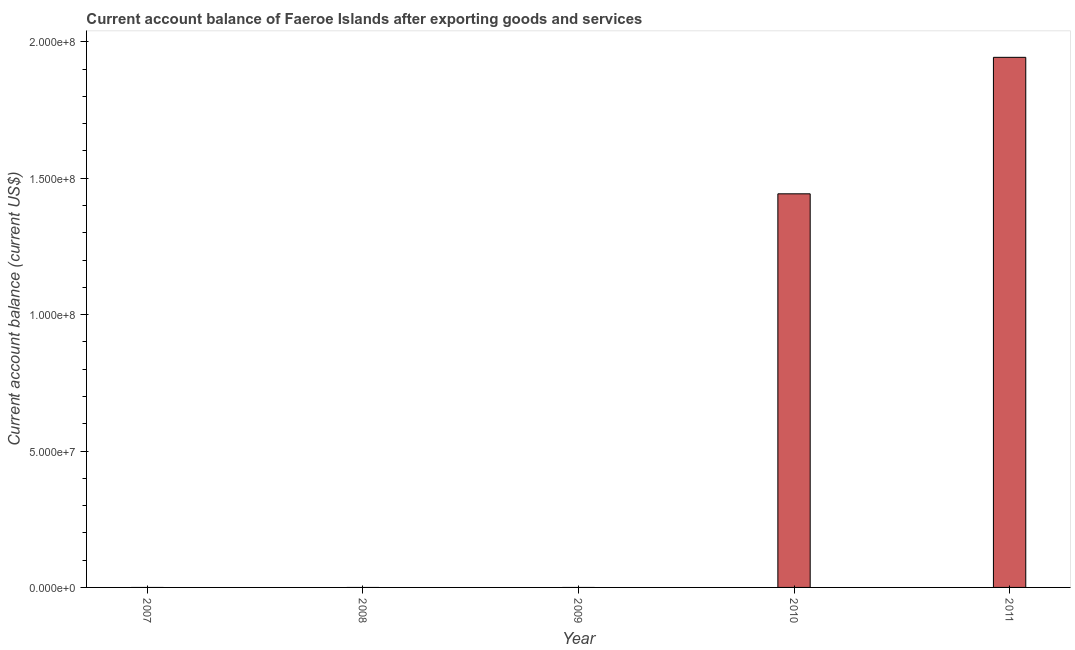Does the graph contain any zero values?
Your answer should be very brief. Yes. What is the title of the graph?
Your answer should be compact. Current account balance of Faeroe Islands after exporting goods and services. What is the label or title of the Y-axis?
Ensure brevity in your answer.  Current account balance (current US$). Across all years, what is the maximum current account balance?
Provide a short and direct response. 1.94e+08. What is the sum of the current account balance?
Give a very brief answer. 3.39e+08. What is the difference between the current account balance in 2010 and 2011?
Provide a succinct answer. -5.00e+07. What is the average current account balance per year?
Provide a short and direct response. 6.77e+07. What is the median current account balance?
Your answer should be very brief. 0. Is the difference between the current account balance in 2010 and 2011 greater than the difference between any two years?
Keep it short and to the point. No. What is the difference between the highest and the lowest current account balance?
Provide a succinct answer. 1.94e+08. Are all the bars in the graph horizontal?
Keep it short and to the point. No. How many years are there in the graph?
Your answer should be compact. 5. What is the difference between two consecutive major ticks on the Y-axis?
Ensure brevity in your answer.  5.00e+07. What is the Current account balance (current US$) in 2007?
Give a very brief answer. 0. What is the Current account balance (current US$) in 2008?
Provide a succinct answer. 0. What is the Current account balance (current US$) in 2009?
Offer a terse response. 0. What is the Current account balance (current US$) of 2010?
Offer a very short reply. 1.44e+08. What is the Current account balance (current US$) in 2011?
Offer a very short reply. 1.94e+08. What is the difference between the Current account balance (current US$) in 2010 and 2011?
Offer a very short reply. -5.00e+07. What is the ratio of the Current account balance (current US$) in 2010 to that in 2011?
Provide a short and direct response. 0.74. 